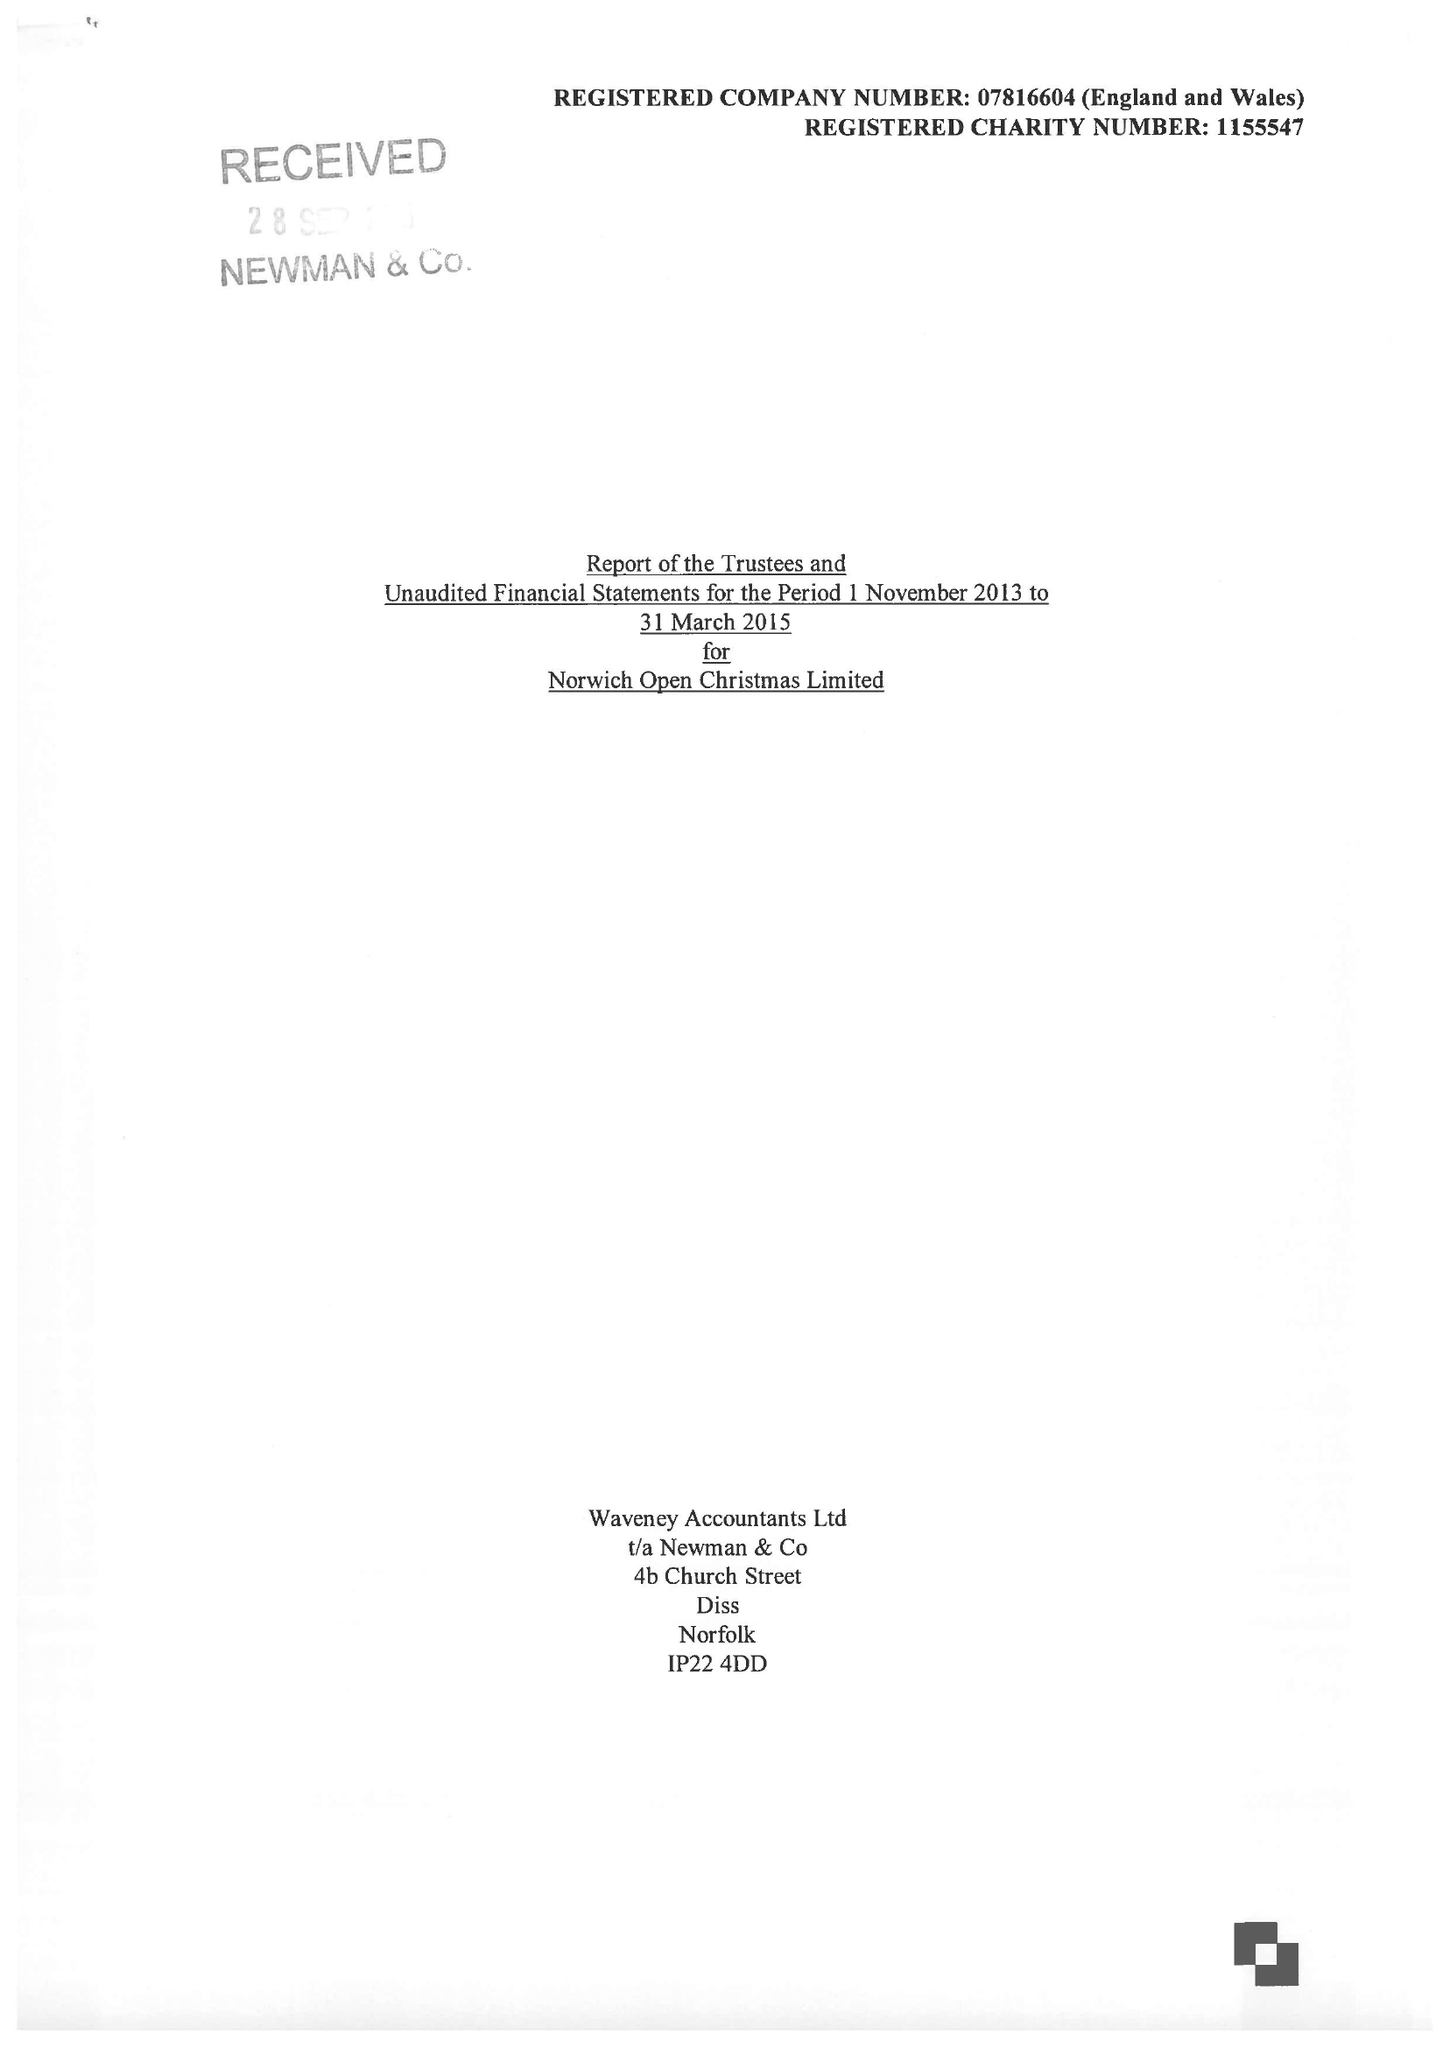What is the value for the address__post_town?
Answer the question using a single word or phrase. NORWICH 